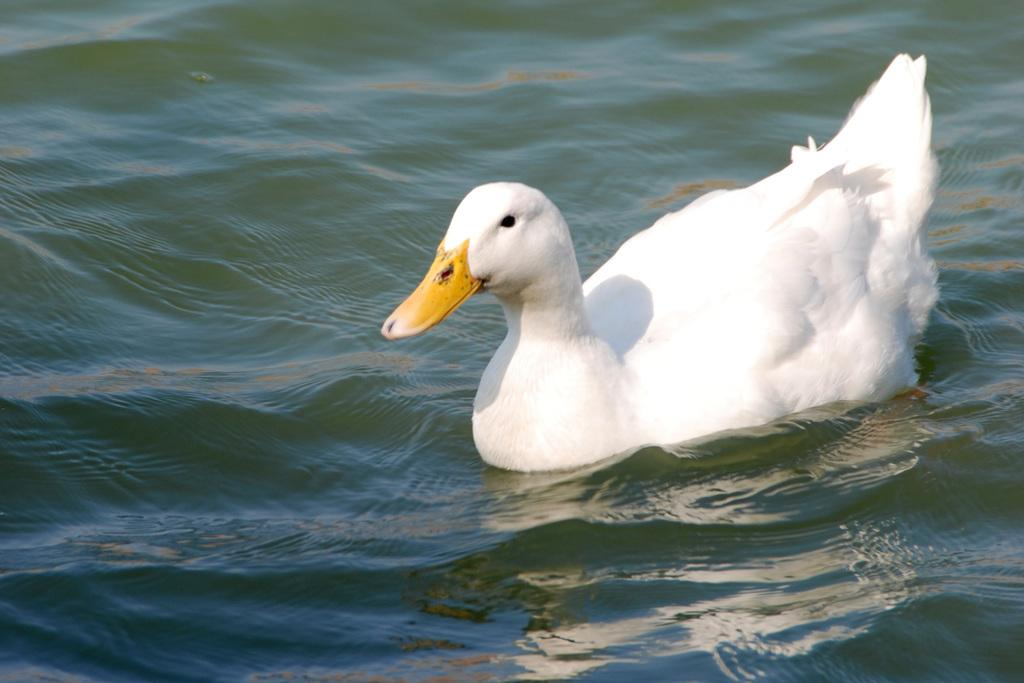What type of animal is in the image? There is a bird in the image. Where is the bird located? The bird is on the water. What colors can be seen on the bird? The bird has white and yellow colors. How many pigs are swimming in the water with the bird? There are no pigs present in the image; it only features a bird on the water. What type of oil can be seen in the image? There is no oil present in the image. 